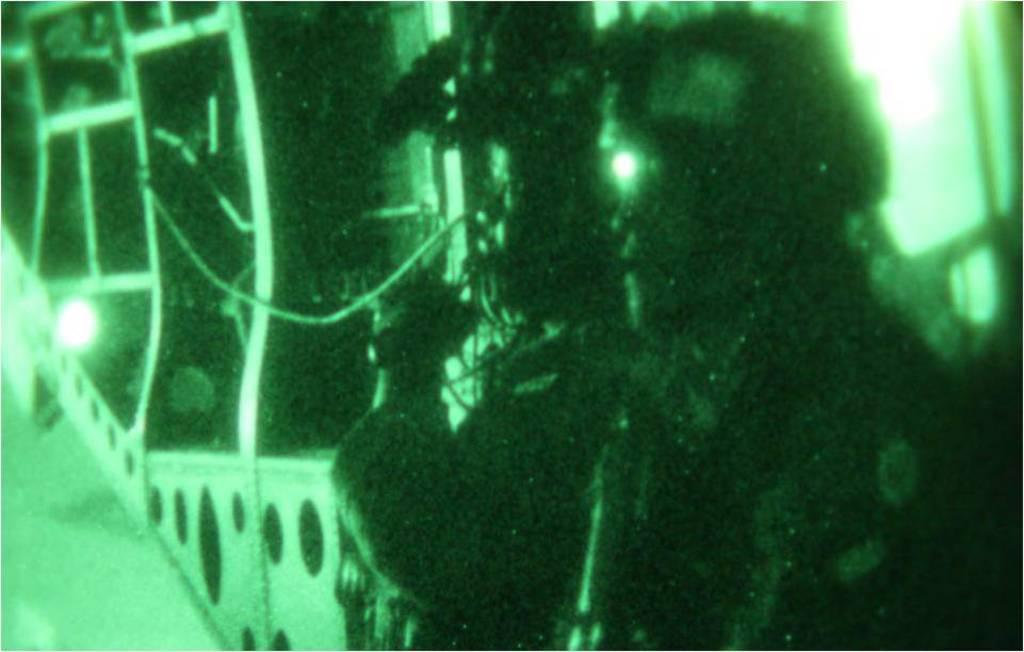What can be seen on the right side of the image? There are two persons on the right side of the image, though it may be less certain due to the blurry nature of the image. What else is visible in the image besides the two persons? Some lights are visible in the image. Is there a woman sitting on the sofa in the image? There is no sofa or woman present in the image; it only shows two persons and some lights. 